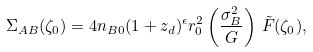Convert formula to latex. <formula><loc_0><loc_0><loc_500><loc_500>\Sigma _ { A B } ( \zeta _ { 0 } ) = 4 n _ { B 0 } ( 1 + z _ { d } ) ^ { \epsilon } r _ { 0 } ^ { 2 } \left ( \frac { \sigma _ { B } ^ { 2 } } { G } \right ) \, \tilde { F } ( \zeta _ { 0 } ) ,</formula> 